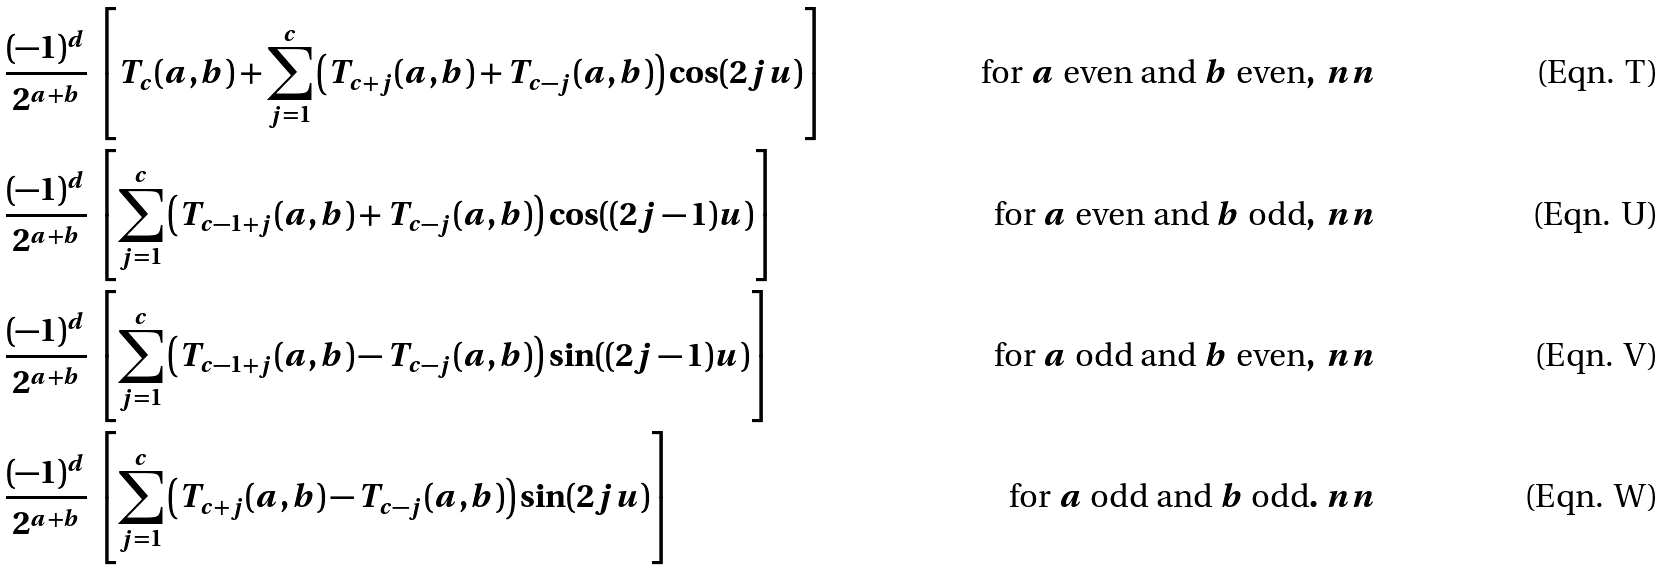<formula> <loc_0><loc_0><loc_500><loc_500>& \frac { ( - 1 ) ^ { d } } { 2 ^ { a + b } } \, \left [ T _ { c } ( a , b ) + \sum _ { j = 1 } ^ { c } \left ( T _ { c + j } ( a , b ) + T _ { c - j } ( a , b ) \right ) \cos ( 2 j u ) \right ] & \text { for } a \text { even and } b \text { even} , \ n n \\ & \frac { ( - 1 ) ^ { d } } { 2 ^ { a + b } } \, \left [ \sum _ { j = 1 } ^ { c } \left ( T _ { c - 1 + j } ( a , b ) + T _ { c - j } ( a , b ) \right ) \cos ( ( 2 j - 1 ) u ) \right ] & \text { for } a \text { even and } b \text { odd} , \ n n \\ & \frac { ( - 1 ) ^ { d } } { 2 ^ { a + b } } \, \left [ \sum _ { j = 1 } ^ { c } \left ( T _ { c - 1 + j } ( a , b ) - T _ { c - j } ( a , b ) \right ) \sin ( ( 2 j - 1 ) u ) \right ] & \text { for } a \text { odd and } b \text { even} , \ n n \\ & \frac { ( - 1 ) ^ { d } } { 2 ^ { a + b } } \, \left [ \sum _ { j = 1 } ^ { c } \left ( T _ { c + j } ( a , b ) - T _ { c - j } ( a , b ) \right ) \sin ( 2 j u ) \right ] & \text { for } a \text { odd and } b \text { odd} . \ n n</formula> 